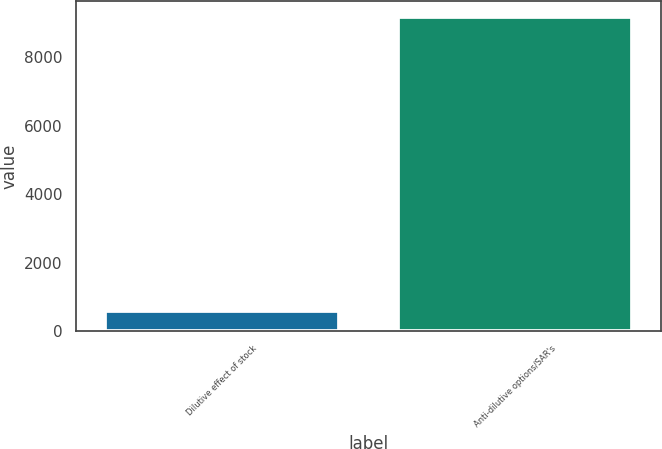Convert chart. <chart><loc_0><loc_0><loc_500><loc_500><bar_chart><fcel>Dilutive effect of stock<fcel>Anti-dilutive options/SAR's<nl><fcel>600<fcel>9176<nl></chart> 